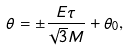<formula> <loc_0><loc_0><loc_500><loc_500>\theta = \pm \frac { E \tau } { \sqrt { 3 } M } + \theta _ { 0 } ,</formula> 